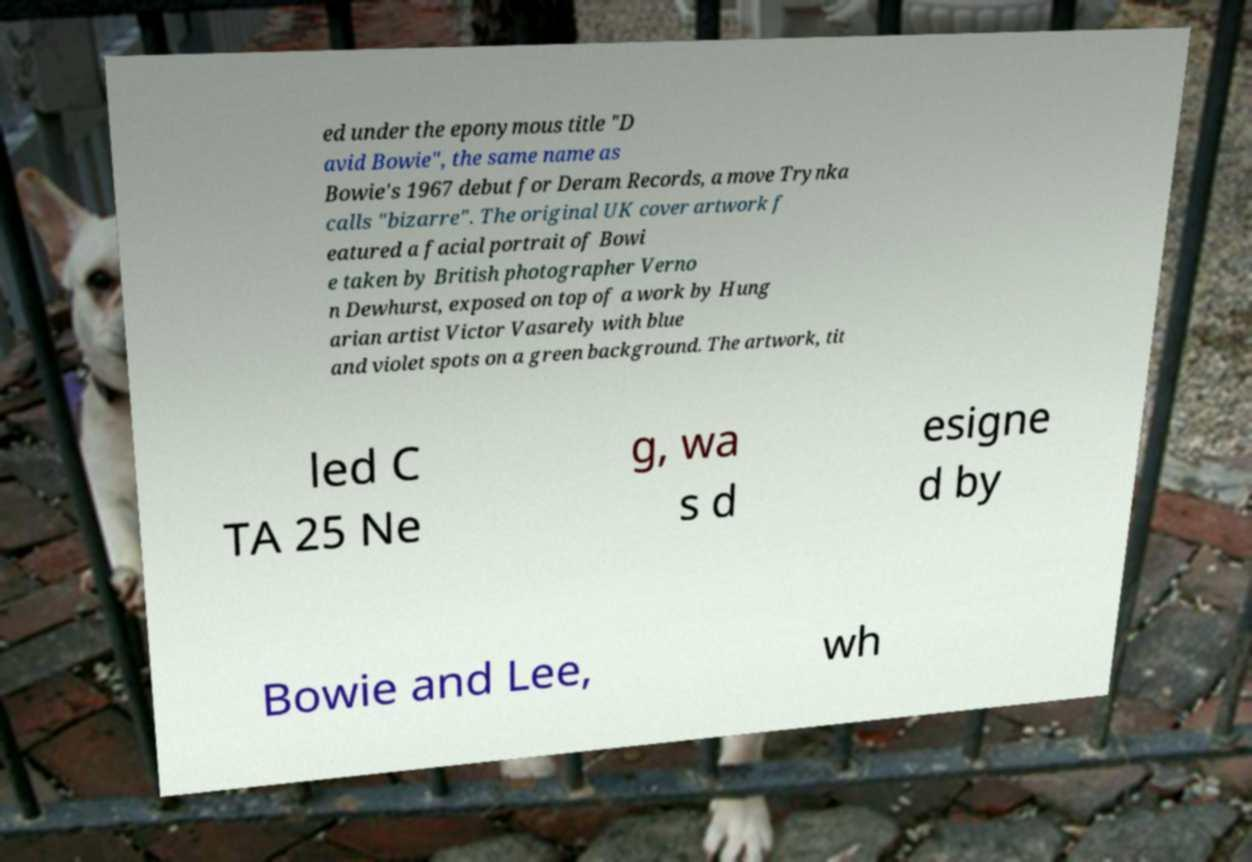Please identify and transcribe the text found in this image. ed under the eponymous title "D avid Bowie", the same name as Bowie's 1967 debut for Deram Records, a move Trynka calls "bizarre". The original UK cover artwork f eatured a facial portrait of Bowi e taken by British photographer Verno n Dewhurst, exposed on top of a work by Hung arian artist Victor Vasarely with blue and violet spots on a green background. The artwork, tit led C TA 25 Ne g, wa s d esigne d by Bowie and Lee, wh 